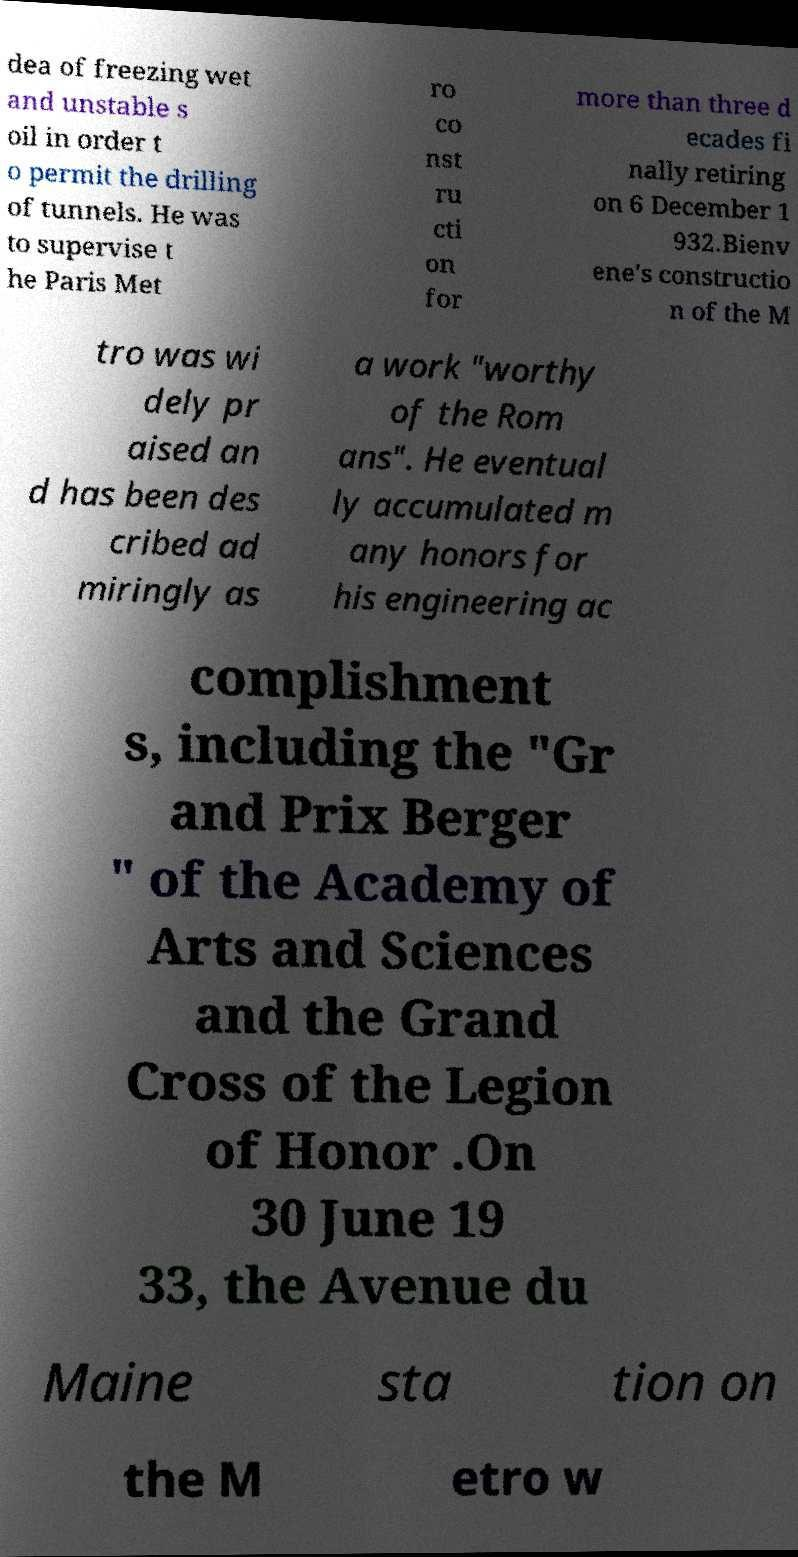Please read and relay the text visible in this image. What does it say? dea of freezing wet and unstable s oil in order t o permit the drilling of tunnels. He was to supervise t he Paris Met ro co nst ru cti on for more than three d ecades fi nally retiring on 6 December 1 932.Bienv ene's constructio n of the M tro was wi dely pr aised an d has been des cribed ad miringly as a work "worthy of the Rom ans". He eventual ly accumulated m any honors for his engineering ac complishment s, including the "Gr and Prix Berger " of the Academy of Arts and Sciences and the Grand Cross of the Legion of Honor .On 30 June 19 33, the Avenue du Maine sta tion on the M etro w 